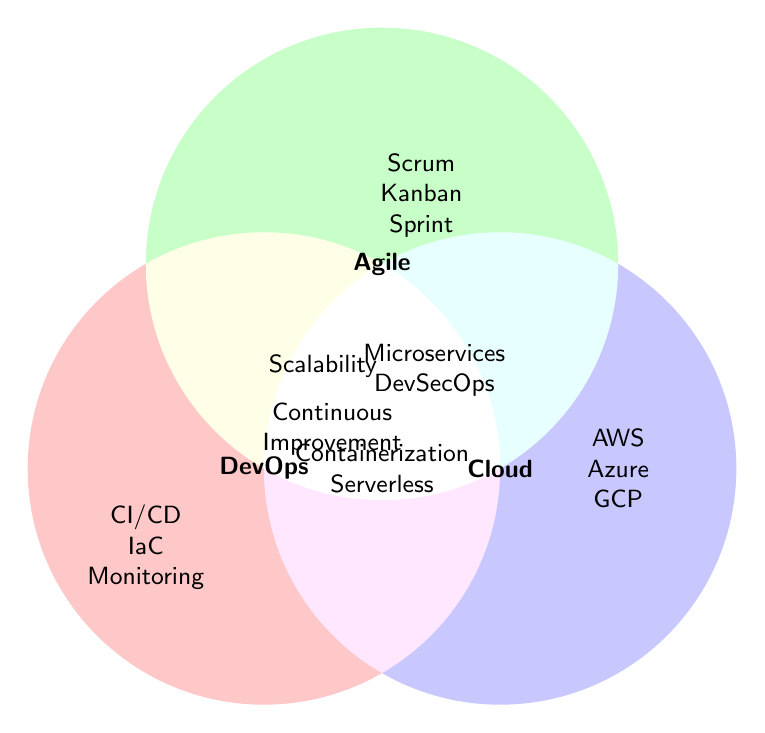What are the three Categories represented in the Venn Diagram? There are three main circles in the Venn Diagram, each labeled differently: one as DevOps, one as Agile, and one as Cloud.
Answer: DevOps, Agile, Cloud Which practices are exclusively listed under DevOps? The figure shows that within the DevOps circle, but not overlapping with others, the practices listed are CI/CD, Infrastructure as Code (IaC), Monitoring, and Automation.
Answer: CI/CD, IaC, Monitoring, Automation What practice is common between DevOps, Agile, and Cloud? The intersection area where all three circles (DevOps, Agile, and Cloud) overlap contains the practices listed. The figure shows "Microservices" and "DevSecOps" in this area.
Answer: Microservices, DevSecOps Which DevOps practice also relates to Cloud? In the overlapping area between the DevOps and Cloud circles, the practices shown are Containerization and Serverless.
Answer: Containerization, Serverless How many practices intersect between DevOps and Agile? The intersection area between the DevOps and Agile circles includes the practices listed in the figure. These practices are Continuous Improvement and Team Collaboration.
Answer: Continuous Improvement, Team Collaboration What is an exclusive practice of Agile mentioned in the diagram? Within the Agile circle, exclusive practices that do not overlap with any other circle are Scrum, Kanban, Sprint Planning, and Retrospectives.
Answer: Scrum, Kanban, Sprint Planning, Retrospectives Which practice relates to both Agile and Cloud? Practices listed in the overlapping area between Agile and Cloud are considered here. The figure shows "Scalability" in this overlapping area.
Answer: Scalability Name all the Cloud platforms mentioned in the Venn Diagram. Counting the platforms listed exclusively within the Cloud circle and not overlapping others, the following Cloud platforms are mentioned: AWS, Azure, and Google Cloud.
Answer: AWS, Azure, Google Cloud 